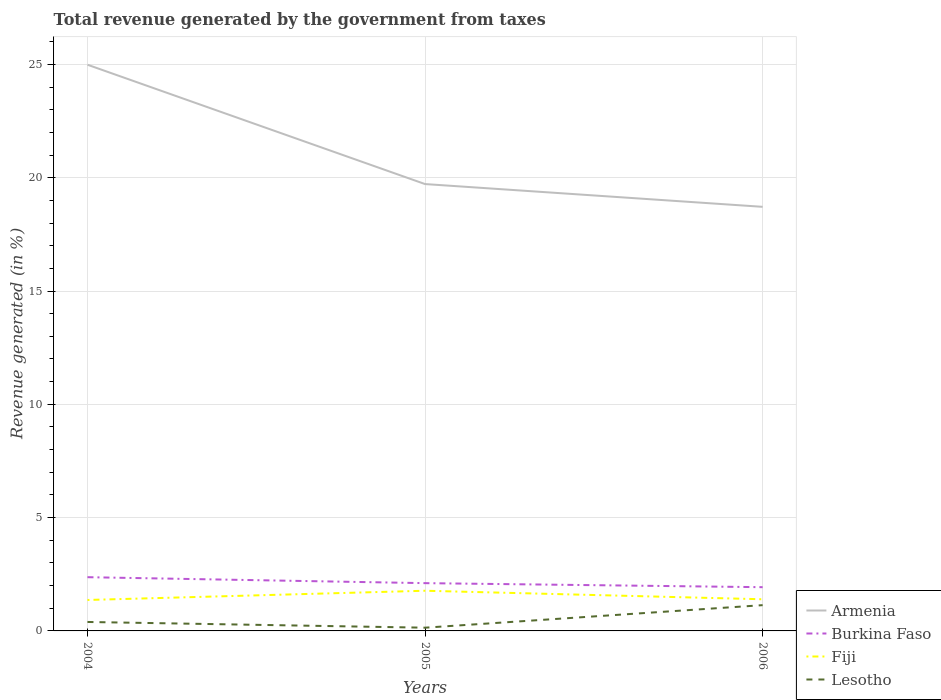Is the number of lines equal to the number of legend labels?
Provide a short and direct response. Yes. Across all years, what is the maximum total revenue generated in Burkina Faso?
Your answer should be very brief. 1.93. In which year was the total revenue generated in Lesotho maximum?
Keep it short and to the point. 2005. What is the total total revenue generated in Armenia in the graph?
Provide a short and direct response. 6.27. What is the difference between the highest and the second highest total revenue generated in Armenia?
Provide a succinct answer. 6.27. What is the difference between the highest and the lowest total revenue generated in Lesotho?
Your answer should be very brief. 1. Is the total revenue generated in Fiji strictly greater than the total revenue generated in Burkina Faso over the years?
Make the answer very short. Yes. Are the values on the major ticks of Y-axis written in scientific E-notation?
Offer a terse response. No. Does the graph contain any zero values?
Your answer should be compact. No. Where does the legend appear in the graph?
Provide a short and direct response. Bottom right. How many legend labels are there?
Your response must be concise. 4. How are the legend labels stacked?
Your answer should be very brief. Vertical. What is the title of the graph?
Your answer should be compact. Total revenue generated by the government from taxes. What is the label or title of the X-axis?
Your answer should be very brief. Years. What is the label or title of the Y-axis?
Your answer should be very brief. Revenue generated (in %). What is the Revenue generated (in %) in Armenia in 2004?
Ensure brevity in your answer.  24.99. What is the Revenue generated (in %) in Burkina Faso in 2004?
Provide a short and direct response. 2.37. What is the Revenue generated (in %) of Fiji in 2004?
Make the answer very short. 1.37. What is the Revenue generated (in %) of Lesotho in 2004?
Offer a very short reply. 0.4. What is the Revenue generated (in %) in Armenia in 2005?
Ensure brevity in your answer.  19.72. What is the Revenue generated (in %) in Burkina Faso in 2005?
Your response must be concise. 2.11. What is the Revenue generated (in %) in Fiji in 2005?
Offer a very short reply. 1.77. What is the Revenue generated (in %) of Lesotho in 2005?
Keep it short and to the point. 0.14. What is the Revenue generated (in %) in Armenia in 2006?
Ensure brevity in your answer.  18.71. What is the Revenue generated (in %) of Burkina Faso in 2006?
Give a very brief answer. 1.93. What is the Revenue generated (in %) in Fiji in 2006?
Give a very brief answer. 1.4. What is the Revenue generated (in %) in Lesotho in 2006?
Offer a terse response. 1.14. Across all years, what is the maximum Revenue generated (in %) in Armenia?
Ensure brevity in your answer.  24.99. Across all years, what is the maximum Revenue generated (in %) in Burkina Faso?
Ensure brevity in your answer.  2.37. Across all years, what is the maximum Revenue generated (in %) in Fiji?
Provide a short and direct response. 1.77. Across all years, what is the maximum Revenue generated (in %) in Lesotho?
Your answer should be compact. 1.14. Across all years, what is the minimum Revenue generated (in %) of Armenia?
Your answer should be compact. 18.71. Across all years, what is the minimum Revenue generated (in %) in Burkina Faso?
Give a very brief answer. 1.93. Across all years, what is the minimum Revenue generated (in %) in Fiji?
Keep it short and to the point. 1.37. Across all years, what is the minimum Revenue generated (in %) of Lesotho?
Provide a succinct answer. 0.14. What is the total Revenue generated (in %) in Armenia in the graph?
Your answer should be compact. 63.42. What is the total Revenue generated (in %) of Burkina Faso in the graph?
Offer a terse response. 6.41. What is the total Revenue generated (in %) in Fiji in the graph?
Provide a succinct answer. 4.54. What is the total Revenue generated (in %) in Lesotho in the graph?
Give a very brief answer. 1.68. What is the difference between the Revenue generated (in %) in Armenia in 2004 and that in 2005?
Your response must be concise. 5.27. What is the difference between the Revenue generated (in %) in Burkina Faso in 2004 and that in 2005?
Your answer should be very brief. 0.26. What is the difference between the Revenue generated (in %) of Fiji in 2004 and that in 2005?
Keep it short and to the point. -0.41. What is the difference between the Revenue generated (in %) in Lesotho in 2004 and that in 2005?
Your response must be concise. 0.25. What is the difference between the Revenue generated (in %) in Armenia in 2004 and that in 2006?
Make the answer very short. 6.27. What is the difference between the Revenue generated (in %) of Burkina Faso in 2004 and that in 2006?
Provide a short and direct response. 0.44. What is the difference between the Revenue generated (in %) of Fiji in 2004 and that in 2006?
Offer a terse response. -0.03. What is the difference between the Revenue generated (in %) of Lesotho in 2004 and that in 2006?
Provide a short and direct response. -0.74. What is the difference between the Revenue generated (in %) in Armenia in 2005 and that in 2006?
Provide a succinct answer. 1. What is the difference between the Revenue generated (in %) in Burkina Faso in 2005 and that in 2006?
Your response must be concise. 0.18. What is the difference between the Revenue generated (in %) of Fiji in 2005 and that in 2006?
Ensure brevity in your answer.  0.38. What is the difference between the Revenue generated (in %) in Lesotho in 2005 and that in 2006?
Ensure brevity in your answer.  -0.99. What is the difference between the Revenue generated (in %) of Armenia in 2004 and the Revenue generated (in %) of Burkina Faso in 2005?
Give a very brief answer. 22.88. What is the difference between the Revenue generated (in %) of Armenia in 2004 and the Revenue generated (in %) of Fiji in 2005?
Give a very brief answer. 23.21. What is the difference between the Revenue generated (in %) of Armenia in 2004 and the Revenue generated (in %) of Lesotho in 2005?
Give a very brief answer. 24.84. What is the difference between the Revenue generated (in %) in Burkina Faso in 2004 and the Revenue generated (in %) in Fiji in 2005?
Provide a short and direct response. 0.6. What is the difference between the Revenue generated (in %) of Burkina Faso in 2004 and the Revenue generated (in %) of Lesotho in 2005?
Ensure brevity in your answer.  2.23. What is the difference between the Revenue generated (in %) in Fiji in 2004 and the Revenue generated (in %) in Lesotho in 2005?
Offer a very short reply. 1.22. What is the difference between the Revenue generated (in %) of Armenia in 2004 and the Revenue generated (in %) of Burkina Faso in 2006?
Offer a terse response. 23.06. What is the difference between the Revenue generated (in %) of Armenia in 2004 and the Revenue generated (in %) of Fiji in 2006?
Your answer should be compact. 23.59. What is the difference between the Revenue generated (in %) in Armenia in 2004 and the Revenue generated (in %) in Lesotho in 2006?
Offer a terse response. 23.85. What is the difference between the Revenue generated (in %) in Burkina Faso in 2004 and the Revenue generated (in %) in Fiji in 2006?
Ensure brevity in your answer.  0.97. What is the difference between the Revenue generated (in %) in Burkina Faso in 2004 and the Revenue generated (in %) in Lesotho in 2006?
Provide a succinct answer. 1.23. What is the difference between the Revenue generated (in %) of Fiji in 2004 and the Revenue generated (in %) of Lesotho in 2006?
Offer a very short reply. 0.23. What is the difference between the Revenue generated (in %) in Armenia in 2005 and the Revenue generated (in %) in Burkina Faso in 2006?
Your answer should be compact. 17.79. What is the difference between the Revenue generated (in %) in Armenia in 2005 and the Revenue generated (in %) in Fiji in 2006?
Ensure brevity in your answer.  18.32. What is the difference between the Revenue generated (in %) in Armenia in 2005 and the Revenue generated (in %) in Lesotho in 2006?
Give a very brief answer. 18.58. What is the difference between the Revenue generated (in %) of Burkina Faso in 2005 and the Revenue generated (in %) of Fiji in 2006?
Ensure brevity in your answer.  0.71. What is the difference between the Revenue generated (in %) in Burkina Faso in 2005 and the Revenue generated (in %) in Lesotho in 2006?
Your response must be concise. 0.97. What is the difference between the Revenue generated (in %) of Fiji in 2005 and the Revenue generated (in %) of Lesotho in 2006?
Keep it short and to the point. 0.64. What is the average Revenue generated (in %) in Armenia per year?
Your response must be concise. 21.14. What is the average Revenue generated (in %) of Burkina Faso per year?
Offer a terse response. 2.14. What is the average Revenue generated (in %) of Fiji per year?
Provide a short and direct response. 1.51. What is the average Revenue generated (in %) of Lesotho per year?
Keep it short and to the point. 0.56. In the year 2004, what is the difference between the Revenue generated (in %) in Armenia and Revenue generated (in %) in Burkina Faso?
Your answer should be compact. 22.61. In the year 2004, what is the difference between the Revenue generated (in %) of Armenia and Revenue generated (in %) of Fiji?
Your answer should be very brief. 23.62. In the year 2004, what is the difference between the Revenue generated (in %) in Armenia and Revenue generated (in %) in Lesotho?
Your answer should be compact. 24.59. In the year 2004, what is the difference between the Revenue generated (in %) in Burkina Faso and Revenue generated (in %) in Lesotho?
Offer a very short reply. 1.98. In the year 2004, what is the difference between the Revenue generated (in %) in Fiji and Revenue generated (in %) in Lesotho?
Offer a terse response. 0.97. In the year 2005, what is the difference between the Revenue generated (in %) in Armenia and Revenue generated (in %) in Burkina Faso?
Provide a short and direct response. 17.61. In the year 2005, what is the difference between the Revenue generated (in %) of Armenia and Revenue generated (in %) of Fiji?
Your response must be concise. 17.95. In the year 2005, what is the difference between the Revenue generated (in %) of Armenia and Revenue generated (in %) of Lesotho?
Offer a terse response. 19.58. In the year 2005, what is the difference between the Revenue generated (in %) in Burkina Faso and Revenue generated (in %) in Fiji?
Your response must be concise. 0.34. In the year 2005, what is the difference between the Revenue generated (in %) in Burkina Faso and Revenue generated (in %) in Lesotho?
Your answer should be very brief. 1.97. In the year 2005, what is the difference between the Revenue generated (in %) in Fiji and Revenue generated (in %) in Lesotho?
Your response must be concise. 1.63. In the year 2006, what is the difference between the Revenue generated (in %) in Armenia and Revenue generated (in %) in Burkina Faso?
Give a very brief answer. 16.78. In the year 2006, what is the difference between the Revenue generated (in %) in Armenia and Revenue generated (in %) in Fiji?
Offer a very short reply. 17.32. In the year 2006, what is the difference between the Revenue generated (in %) in Armenia and Revenue generated (in %) in Lesotho?
Offer a terse response. 17.58. In the year 2006, what is the difference between the Revenue generated (in %) in Burkina Faso and Revenue generated (in %) in Fiji?
Give a very brief answer. 0.53. In the year 2006, what is the difference between the Revenue generated (in %) in Burkina Faso and Revenue generated (in %) in Lesotho?
Provide a succinct answer. 0.79. In the year 2006, what is the difference between the Revenue generated (in %) of Fiji and Revenue generated (in %) of Lesotho?
Keep it short and to the point. 0.26. What is the ratio of the Revenue generated (in %) of Armenia in 2004 to that in 2005?
Give a very brief answer. 1.27. What is the ratio of the Revenue generated (in %) of Burkina Faso in 2004 to that in 2005?
Give a very brief answer. 1.12. What is the ratio of the Revenue generated (in %) in Fiji in 2004 to that in 2005?
Your answer should be very brief. 0.77. What is the ratio of the Revenue generated (in %) in Lesotho in 2004 to that in 2005?
Make the answer very short. 2.77. What is the ratio of the Revenue generated (in %) in Armenia in 2004 to that in 2006?
Offer a terse response. 1.34. What is the ratio of the Revenue generated (in %) of Burkina Faso in 2004 to that in 2006?
Your answer should be compact. 1.23. What is the ratio of the Revenue generated (in %) of Fiji in 2004 to that in 2006?
Your answer should be very brief. 0.98. What is the ratio of the Revenue generated (in %) in Lesotho in 2004 to that in 2006?
Your answer should be very brief. 0.35. What is the ratio of the Revenue generated (in %) in Armenia in 2005 to that in 2006?
Your response must be concise. 1.05. What is the ratio of the Revenue generated (in %) in Burkina Faso in 2005 to that in 2006?
Provide a short and direct response. 1.09. What is the ratio of the Revenue generated (in %) in Fiji in 2005 to that in 2006?
Your answer should be compact. 1.27. What is the ratio of the Revenue generated (in %) of Lesotho in 2005 to that in 2006?
Ensure brevity in your answer.  0.13. What is the difference between the highest and the second highest Revenue generated (in %) of Armenia?
Give a very brief answer. 5.27. What is the difference between the highest and the second highest Revenue generated (in %) in Burkina Faso?
Offer a very short reply. 0.26. What is the difference between the highest and the second highest Revenue generated (in %) of Fiji?
Your answer should be compact. 0.38. What is the difference between the highest and the second highest Revenue generated (in %) of Lesotho?
Offer a very short reply. 0.74. What is the difference between the highest and the lowest Revenue generated (in %) in Armenia?
Offer a very short reply. 6.27. What is the difference between the highest and the lowest Revenue generated (in %) in Burkina Faso?
Provide a succinct answer. 0.44. What is the difference between the highest and the lowest Revenue generated (in %) of Fiji?
Keep it short and to the point. 0.41. What is the difference between the highest and the lowest Revenue generated (in %) in Lesotho?
Keep it short and to the point. 0.99. 